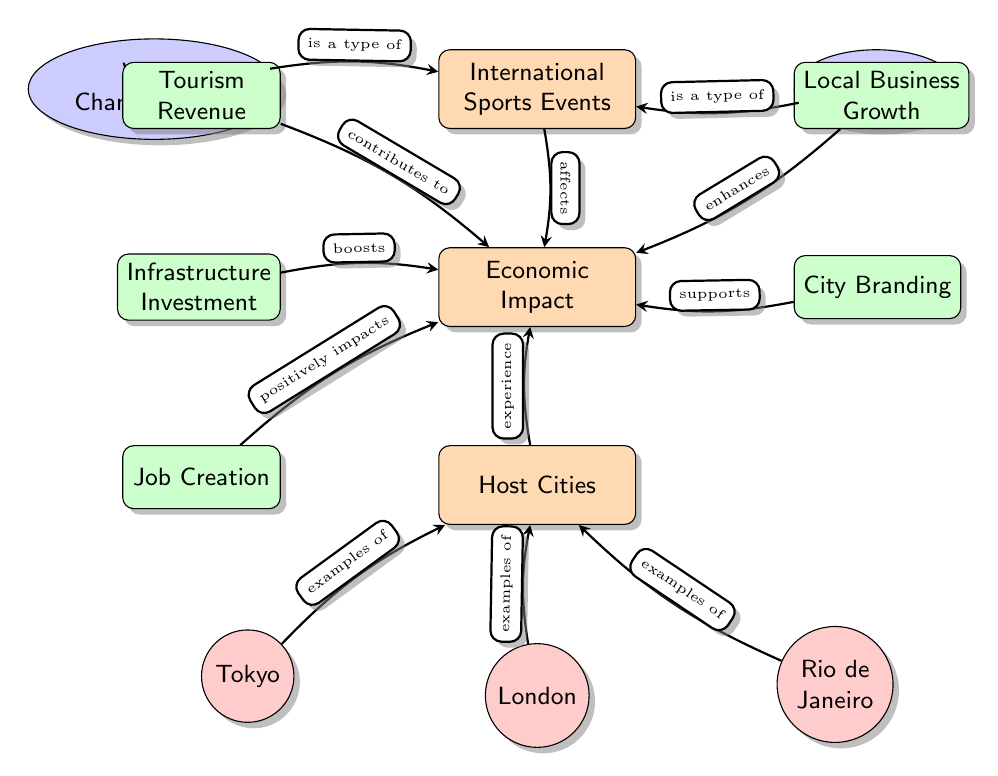What are the two types of International Sports Events mentioned? The diagram shows two nodes labeled "World Championships" and "Olympics" under the main category of "International Sports Events."
Answer: World Championships, Olympics How many cities are listed as examples of Host Cities? There are three city nodes in the diagram: Tokyo, London, and Rio de Janeiro, which indicate the examples of Host Cities.
Answer: Three What contributes to Tourism Revenue in the Economic Impact? The diagram indicates that "Tourism Revenue" is connected to "Economic Impact" with the arrow labeled "contributes to."
Answer: Tourism Revenue Which factor positively impacts Economic Impact? The diagram shows a node labeled "Job Creation" that connects to "Economic Impact" with an arrow labeled "positively impacts."
Answer: Job Creation What is the relationship between Host Cities and Economic Impact? The diagram presents a connection that suggests Host Cities experience the Economic Impact, indicated by the arrow labeled "experience."
Answer: experience Which node enhances Economic Impact? The node "Local Business Growth" is linked to "Economic Impact" with an arrow labeled "enhances," indicating its positive influence.
Answer: Local Business Growth Which type of International Sports Event is shown on the left of the diagram? The diagram displays "World Championships" to the left side of the central node "International Sports Events."
Answer: World Championships What supports City Branding in the Economic Impact? The diagram illustrates a connection where "City Branding" supports the "Economic Impact," indicated by the arrow labeled "supports."
Answer: City Branding In the diagram, what is the main focus? The diagram centers around the main node "Economic Impact," which is influenced by various contributing factors and events.
Answer: Economic Impact 